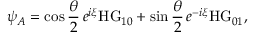<formula> <loc_0><loc_0><loc_500><loc_500>\psi _ { A } = \cos { \frac { \theta } { 2 } } \, e ^ { i \xi } H G _ { 1 0 } + \sin { \frac { \theta } { 2 } } \, e ^ { - i \xi } H G _ { 0 1 } ,</formula> 